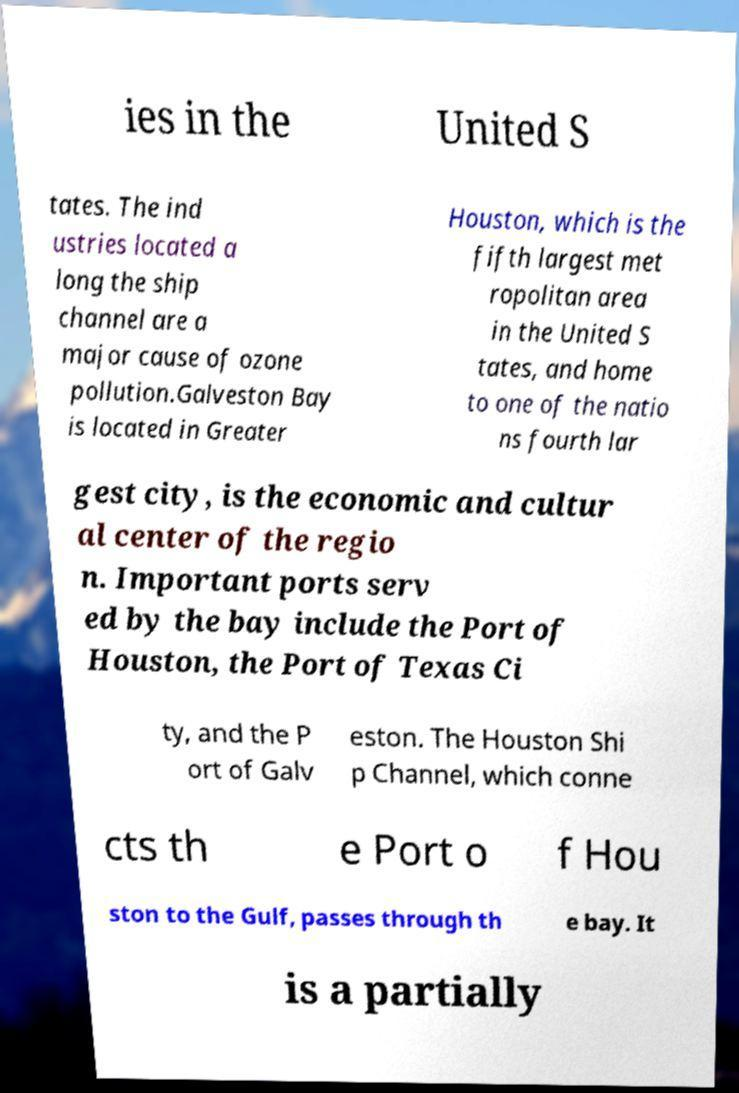What messages or text are displayed in this image? I need them in a readable, typed format. ies in the United S tates. The ind ustries located a long the ship channel are a major cause of ozone pollution.Galveston Bay is located in Greater Houston, which is the fifth largest met ropolitan area in the United S tates, and home to one of the natio ns fourth lar gest city, is the economic and cultur al center of the regio n. Important ports serv ed by the bay include the Port of Houston, the Port of Texas Ci ty, and the P ort of Galv eston. The Houston Shi p Channel, which conne cts th e Port o f Hou ston to the Gulf, passes through th e bay. It is a partially 